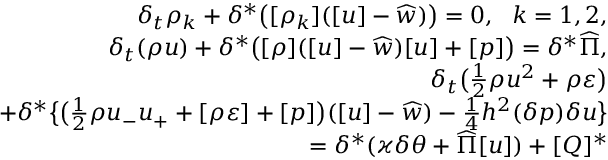Convert formula to latex. <formula><loc_0><loc_0><loc_500><loc_500>\begin{array} { r } { \delta _ { t } \rho _ { k } + \delta ^ { * } \left ( [ \rho _ { k } ] ( [ u ] - \widehat { w } ) \right ) = 0 , \ \ k = 1 , 2 , } \\ { \delta _ { t } ( \rho u ) + \delta ^ { * } \left ( [ \rho ] ( [ u ] - \widehat { w } ) [ u ] + [ p ] \right ) = \delta ^ { * } \widehat { \Pi } , } \\ { \delta _ { t } \left ( \frac { 1 } { 2 } \rho u ^ { 2 } + \rho \varepsilon \right ) } \\ { + \delta ^ { * } \left \{ \left ( \frac { 1 } { 2 } \rho u _ { - } u _ { + } + [ \rho \varepsilon ] + [ p ] \right ) ( [ u ] - \widehat { w } ) - \frac { 1 } { 4 } h ^ { 2 } ( \delta p ) \delta u \right \} } \\ { = \delta ^ { * } ( \varkappa \delta \theta + \widehat { \Pi } [ u ] ) + [ Q ] ^ { * } } \end{array}</formula> 